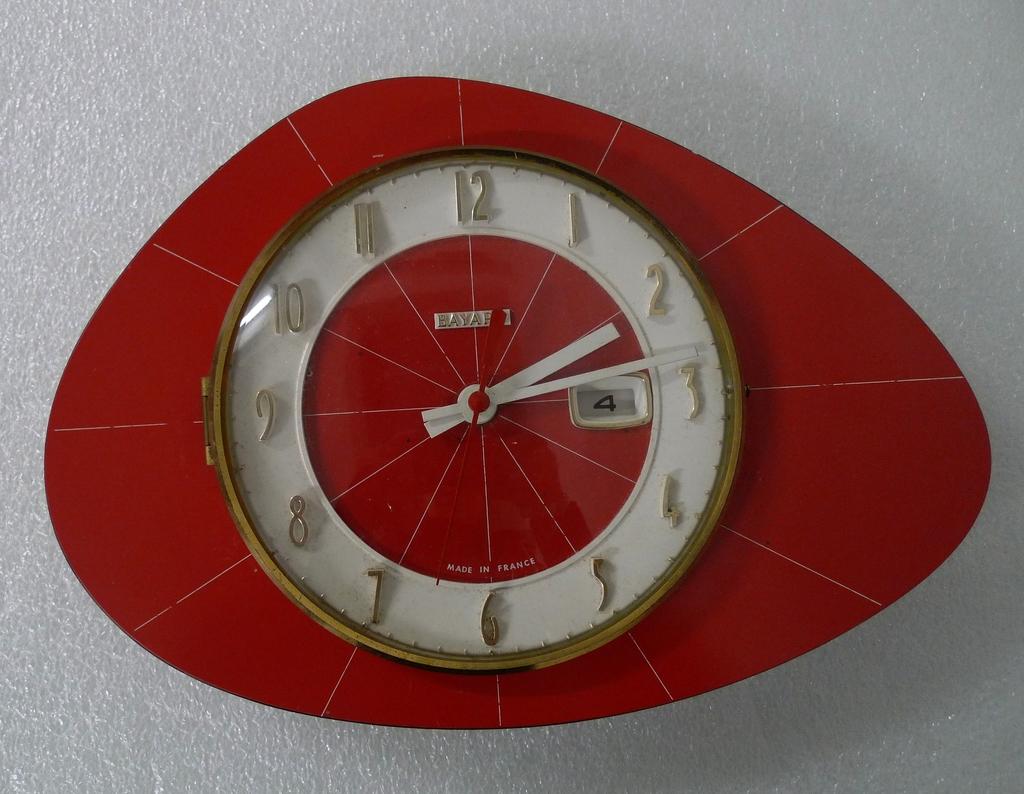What number is in the white box within the clock?
Provide a succinct answer. 4. Is this a clock?
Provide a succinct answer. Yes. 